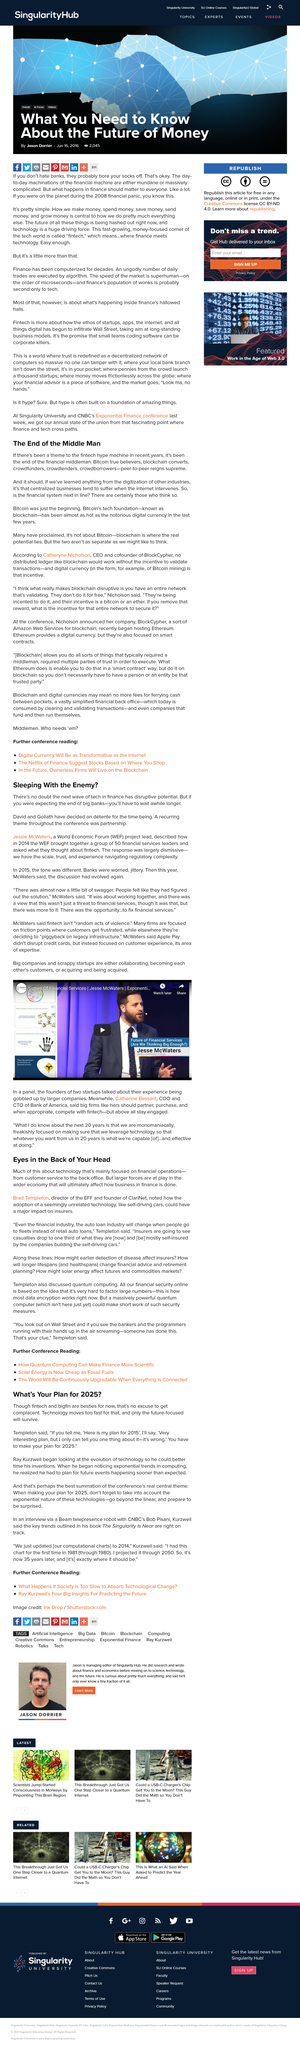Draw attention to some important aspects in this diagram. The real central theme of the conference is the exponential nature of technologies, which requires a plan for 2025 that goes beyond the linear and prepares to be surprised. In 2015, banks were experiencing feelings of worry and jitteriness due to various factors such as economic uncertainty and stricter regulatory requirements. The article states that the beginning has only just occurred and that it is Bitcoin. ClariNet was founded by Brad Templeton. Ray Kurzweil began to examine the evolution of technology in order to more accurately predict and time the development of his inventions. 